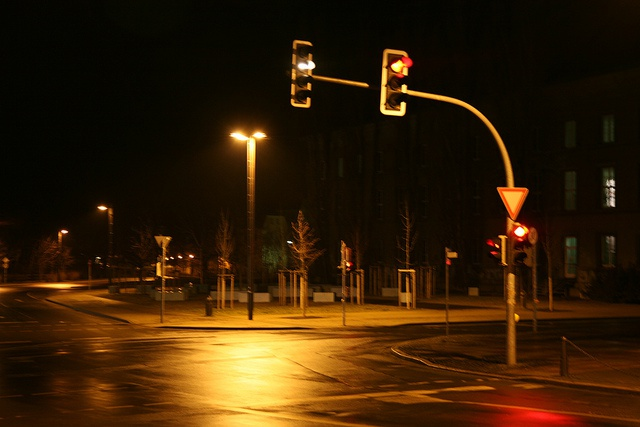Describe the objects in this image and their specific colors. I can see traffic light in black, maroon, gold, and orange tones, traffic light in black, brown, maroon, and orange tones, traffic light in black, maroon, and orange tones, traffic light in black, maroon, white, and red tones, and traffic light in black, red, maroon, and brown tones in this image. 